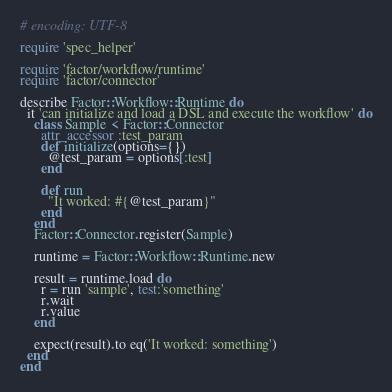Convert code to text. <code><loc_0><loc_0><loc_500><loc_500><_Ruby_># encoding: UTF-8

require 'spec_helper'

require 'factor/workflow/runtime'
require 'factor/connector'

describe Factor::Workflow::Runtime do
  it 'can initialize and load a DSL and execute the workflow' do
    class Sample < Factor::Connector
      attr_accessor :test_param
      def initialize(options={})
        @test_param = options[:test]
      end

      def run
        "It worked: #{@test_param}"
      end
    end
    Factor::Connector.register(Sample)

    runtime = Factor::Workflow::Runtime.new

    result = runtime.load do
      r = run 'sample', test:'something'
      r.wait
      r.value
    end

    expect(result).to eq('It worked: something')
  end
end
</code> 